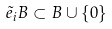Convert formula to latex. <formula><loc_0><loc_0><loc_500><loc_500>\tilde { e } _ { i } B \subset B \cup \{ 0 \}</formula> 